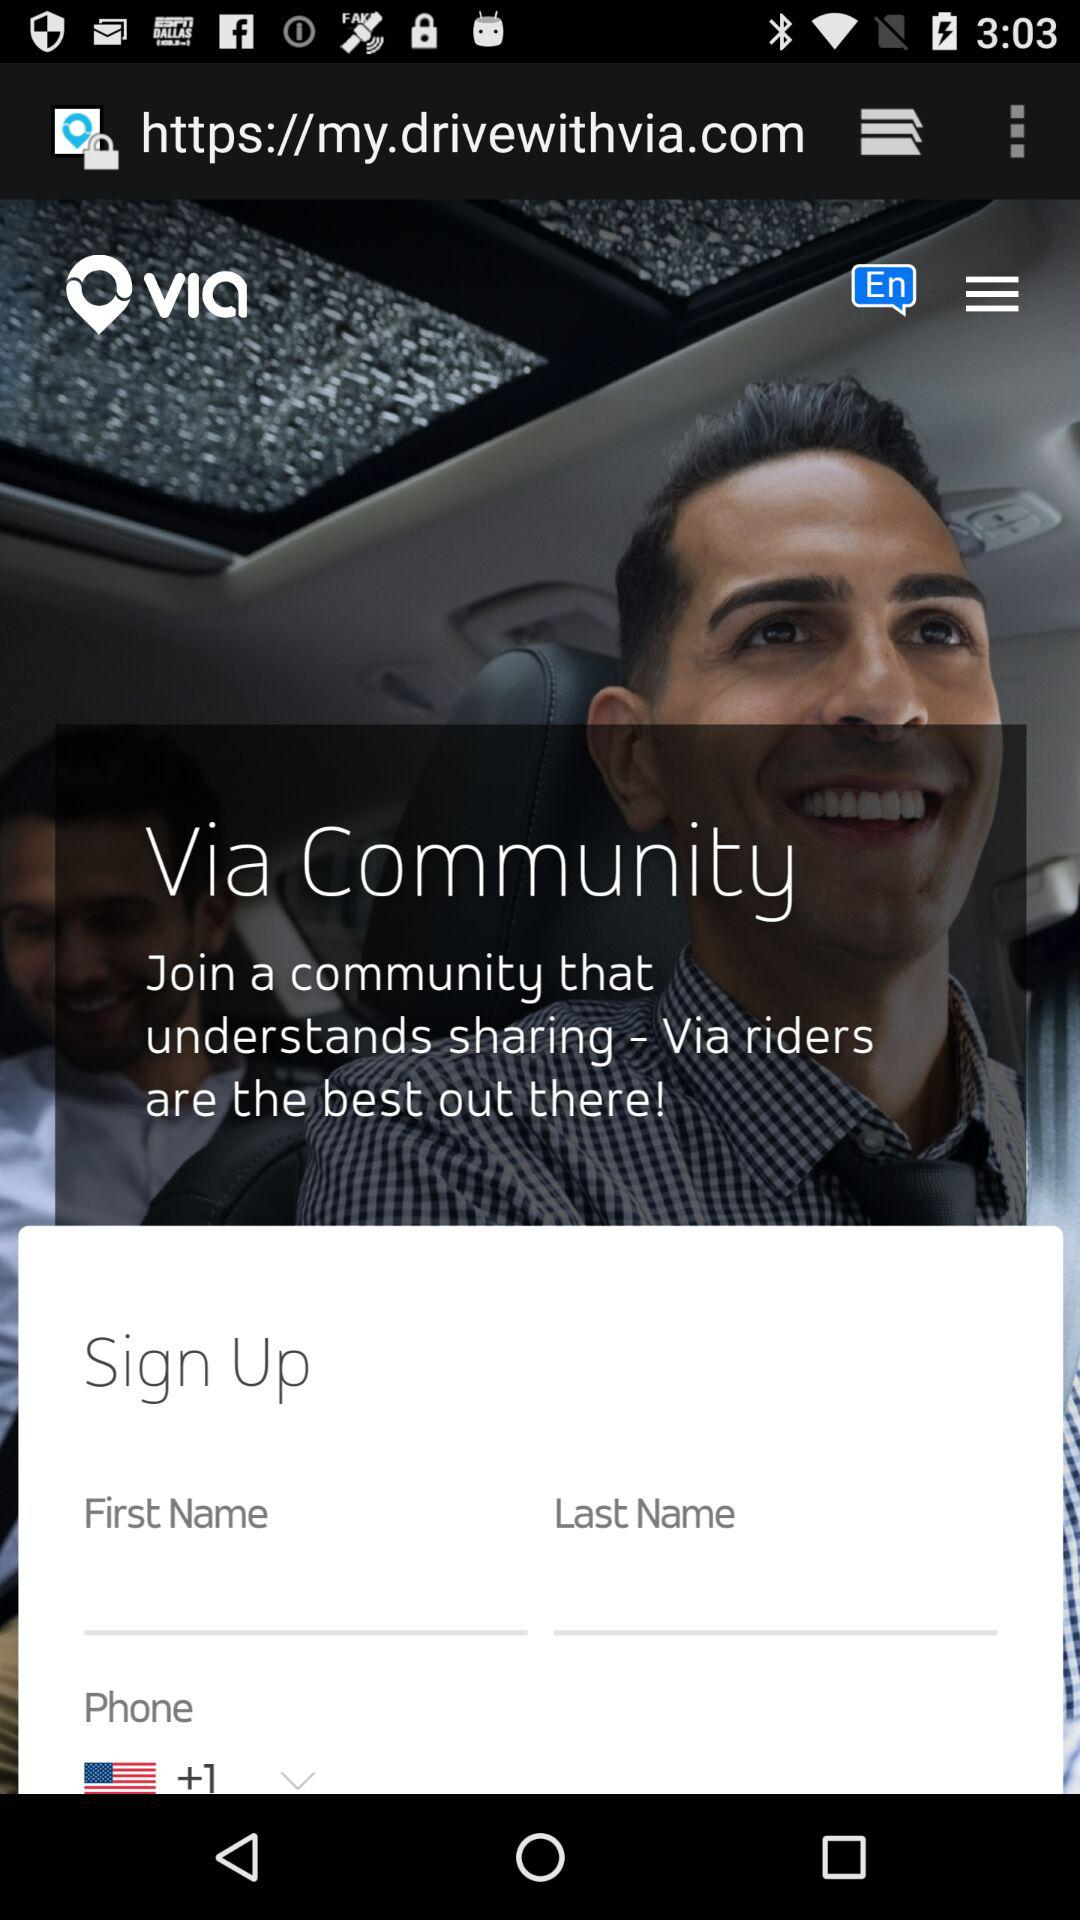What is the application name? The application name is "via". 